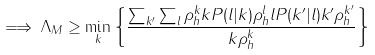<formula> <loc_0><loc_0><loc_500><loc_500>\implies \Lambda _ { M } \geq \min _ { k } \left \{ \frac { \sum _ { k ^ { \prime } } \sum _ { l } \rho _ { h } ^ { k } k P ( l | k ) \rho _ { h } ^ { l } l P ( k ^ { \prime } | l ) k ^ { \prime } \rho _ { h } ^ { k ^ { \prime } } } { k \rho _ { h } ^ { k } } \right \}</formula> 